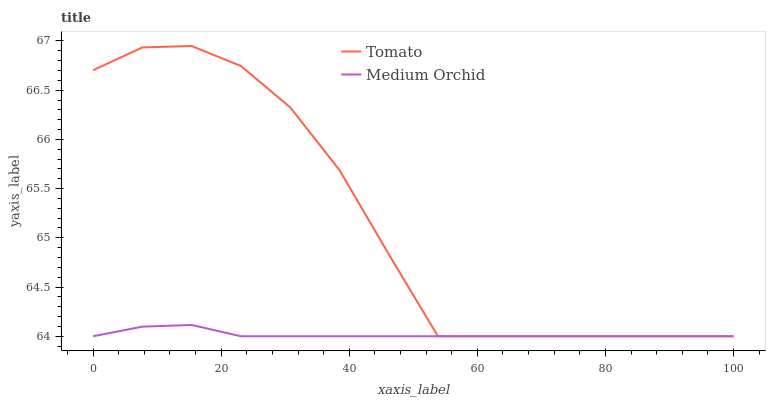Does Medium Orchid have the minimum area under the curve?
Answer yes or no. Yes. Does Tomato have the maximum area under the curve?
Answer yes or no. Yes. Does Medium Orchid have the maximum area under the curve?
Answer yes or no. No. Is Medium Orchid the smoothest?
Answer yes or no. Yes. Is Tomato the roughest?
Answer yes or no. Yes. Is Medium Orchid the roughest?
Answer yes or no. No. Does Tomato have the lowest value?
Answer yes or no. Yes. Does Tomato have the highest value?
Answer yes or no. Yes. Does Medium Orchid have the highest value?
Answer yes or no. No. Does Medium Orchid intersect Tomato?
Answer yes or no. Yes. Is Medium Orchid less than Tomato?
Answer yes or no. No. Is Medium Orchid greater than Tomato?
Answer yes or no. No. 